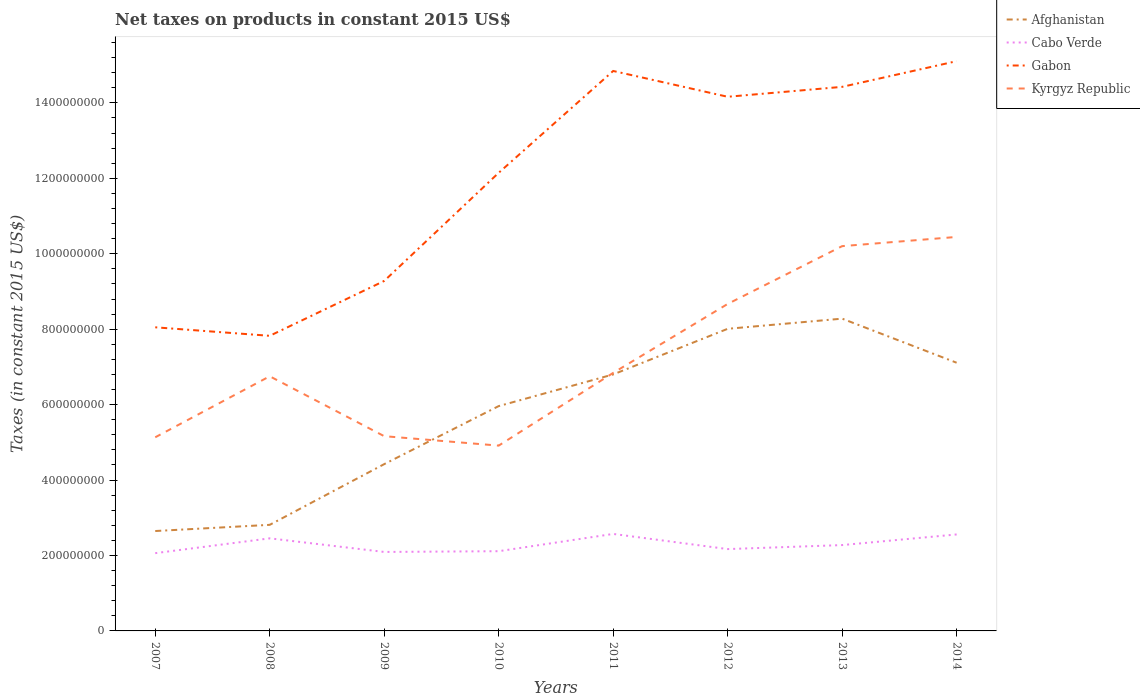Does the line corresponding to Gabon intersect with the line corresponding to Afghanistan?
Give a very brief answer. No. Across all years, what is the maximum net taxes on products in Afghanistan?
Give a very brief answer. 2.65e+08. In which year was the net taxes on products in Kyrgyz Republic maximum?
Offer a very short reply. 2010. What is the total net taxes on products in Afghanistan in the graph?
Offer a very short reply. -2.38e+08. What is the difference between the highest and the second highest net taxes on products in Cabo Verde?
Your response must be concise. 5.10e+07. What is the difference between the highest and the lowest net taxes on products in Afghanistan?
Offer a very short reply. 5. How many lines are there?
Your answer should be very brief. 4. How many years are there in the graph?
Make the answer very short. 8. What is the difference between two consecutive major ticks on the Y-axis?
Your answer should be compact. 2.00e+08. Does the graph contain any zero values?
Give a very brief answer. No. Does the graph contain grids?
Give a very brief answer. No. Where does the legend appear in the graph?
Your answer should be compact. Top right. What is the title of the graph?
Make the answer very short. Net taxes on products in constant 2015 US$. Does "Japan" appear as one of the legend labels in the graph?
Make the answer very short. No. What is the label or title of the X-axis?
Offer a terse response. Years. What is the label or title of the Y-axis?
Give a very brief answer. Taxes (in constant 2015 US$). What is the Taxes (in constant 2015 US$) of Afghanistan in 2007?
Offer a terse response. 2.65e+08. What is the Taxes (in constant 2015 US$) of Cabo Verde in 2007?
Your answer should be compact. 2.06e+08. What is the Taxes (in constant 2015 US$) of Gabon in 2007?
Provide a short and direct response. 8.05e+08. What is the Taxes (in constant 2015 US$) of Kyrgyz Republic in 2007?
Your answer should be very brief. 5.13e+08. What is the Taxes (in constant 2015 US$) in Afghanistan in 2008?
Your answer should be compact. 2.81e+08. What is the Taxes (in constant 2015 US$) in Cabo Verde in 2008?
Keep it short and to the point. 2.45e+08. What is the Taxes (in constant 2015 US$) of Gabon in 2008?
Your answer should be very brief. 7.82e+08. What is the Taxes (in constant 2015 US$) of Kyrgyz Republic in 2008?
Offer a terse response. 6.75e+08. What is the Taxes (in constant 2015 US$) of Afghanistan in 2009?
Provide a short and direct response. 4.42e+08. What is the Taxes (in constant 2015 US$) of Cabo Verde in 2009?
Ensure brevity in your answer.  2.09e+08. What is the Taxes (in constant 2015 US$) of Gabon in 2009?
Offer a very short reply. 9.28e+08. What is the Taxes (in constant 2015 US$) in Kyrgyz Republic in 2009?
Keep it short and to the point. 5.16e+08. What is the Taxes (in constant 2015 US$) of Afghanistan in 2010?
Offer a terse response. 5.96e+08. What is the Taxes (in constant 2015 US$) of Cabo Verde in 2010?
Your answer should be very brief. 2.11e+08. What is the Taxes (in constant 2015 US$) of Gabon in 2010?
Give a very brief answer. 1.21e+09. What is the Taxes (in constant 2015 US$) of Kyrgyz Republic in 2010?
Your response must be concise. 4.91e+08. What is the Taxes (in constant 2015 US$) of Afghanistan in 2011?
Keep it short and to the point. 6.80e+08. What is the Taxes (in constant 2015 US$) of Cabo Verde in 2011?
Keep it short and to the point. 2.57e+08. What is the Taxes (in constant 2015 US$) in Gabon in 2011?
Keep it short and to the point. 1.48e+09. What is the Taxes (in constant 2015 US$) of Kyrgyz Republic in 2011?
Provide a short and direct response. 6.84e+08. What is the Taxes (in constant 2015 US$) in Afghanistan in 2012?
Keep it short and to the point. 8.01e+08. What is the Taxes (in constant 2015 US$) in Cabo Verde in 2012?
Offer a very short reply. 2.17e+08. What is the Taxes (in constant 2015 US$) of Gabon in 2012?
Provide a short and direct response. 1.42e+09. What is the Taxes (in constant 2015 US$) in Kyrgyz Republic in 2012?
Offer a terse response. 8.67e+08. What is the Taxes (in constant 2015 US$) of Afghanistan in 2013?
Give a very brief answer. 8.28e+08. What is the Taxes (in constant 2015 US$) in Cabo Verde in 2013?
Keep it short and to the point. 2.28e+08. What is the Taxes (in constant 2015 US$) of Gabon in 2013?
Offer a very short reply. 1.44e+09. What is the Taxes (in constant 2015 US$) of Kyrgyz Republic in 2013?
Provide a succinct answer. 1.02e+09. What is the Taxes (in constant 2015 US$) in Afghanistan in 2014?
Provide a succinct answer. 7.11e+08. What is the Taxes (in constant 2015 US$) of Cabo Verde in 2014?
Offer a terse response. 2.56e+08. What is the Taxes (in constant 2015 US$) of Gabon in 2014?
Offer a terse response. 1.51e+09. What is the Taxes (in constant 2015 US$) in Kyrgyz Republic in 2014?
Your response must be concise. 1.04e+09. Across all years, what is the maximum Taxes (in constant 2015 US$) in Afghanistan?
Your answer should be very brief. 8.28e+08. Across all years, what is the maximum Taxes (in constant 2015 US$) of Cabo Verde?
Offer a very short reply. 2.57e+08. Across all years, what is the maximum Taxes (in constant 2015 US$) of Gabon?
Give a very brief answer. 1.51e+09. Across all years, what is the maximum Taxes (in constant 2015 US$) in Kyrgyz Republic?
Offer a terse response. 1.04e+09. Across all years, what is the minimum Taxes (in constant 2015 US$) in Afghanistan?
Offer a very short reply. 2.65e+08. Across all years, what is the minimum Taxes (in constant 2015 US$) in Cabo Verde?
Your answer should be very brief. 2.06e+08. Across all years, what is the minimum Taxes (in constant 2015 US$) in Gabon?
Ensure brevity in your answer.  7.82e+08. Across all years, what is the minimum Taxes (in constant 2015 US$) in Kyrgyz Republic?
Offer a terse response. 4.91e+08. What is the total Taxes (in constant 2015 US$) in Afghanistan in the graph?
Your response must be concise. 4.60e+09. What is the total Taxes (in constant 2015 US$) of Cabo Verde in the graph?
Give a very brief answer. 1.83e+09. What is the total Taxes (in constant 2015 US$) in Gabon in the graph?
Your answer should be compact. 9.58e+09. What is the total Taxes (in constant 2015 US$) in Kyrgyz Republic in the graph?
Give a very brief answer. 5.81e+09. What is the difference between the Taxes (in constant 2015 US$) in Afghanistan in 2007 and that in 2008?
Provide a succinct answer. -1.64e+07. What is the difference between the Taxes (in constant 2015 US$) in Cabo Verde in 2007 and that in 2008?
Your answer should be very brief. -3.93e+07. What is the difference between the Taxes (in constant 2015 US$) of Gabon in 2007 and that in 2008?
Your response must be concise. 2.26e+07. What is the difference between the Taxes (in constant 2015 US$) of Kyrgyz Republic in 2007 and that in 2008?
Your answer should be very brief. -1.62e+08. What is the difference between the Taxes (in constant 2015 US$) of Afghanistan in 2007 and that in 2009?
Make the answer very short. -1.77e+08. What is the difference between the Taxes (in constant 2015 US$) of Cabo Verde in 2007 and that in 2009?
Your answer should be compact. -3.21e+06. What is the difference between the Taxes (in constant 2015 US$) of Gabon in 2007 and that in 2009?
Provide a succinct answer. -1.23e+08. What is the difference between the Taxes (in constant 2015 US$) in Kyrgyz Republic in 2007 and that in 2009?
Keep it short and to the point. -2.94e+06. What is the difference between the Taxes (in constant 2015 US$) in Afghanistan in 2007 and that in 2010?
Give a very brief answer. -3.31e+08. What is the difference between the Taxes (in constant 2015 US$) of Cabo Verde in 2007 and that in 2010?
Your answer should be very brief. -5.19e+06. What is the difference between the Taxes (in constant 2015 US$) of Gabon in 2007 and that in 2010?
Offer a terse response. -4.10e+08. What is the difference between the Taxes (in constant 2015 US$) in Kyrgyz Republic in 2007 and that in 2010?
Your answer should be very brief. 2.21e+07. What is the difference between the Taxes (in constant 2015 US$) in Afghanistan in 2007 and that in 2011?
Your answer should be very brief. -4.15e+08. What is the difference between the Taxes (in constant 2015 US$) of Cabo Verde in 2007 and that in 2011?
Keep it short and to the point. -5.10e+07. What is the difference between the Taxes (in constant 2015 US$) of Gabon in 2007 and that in 2011?
Provide a succinct answer. -6.80e+08. What is the difference between the Taxes (in constant 2015 US$) in Kyrgyz Republic in 2007 and that in 2011?
Your answer should be very brief. -1.71e+08. What is the difference between the Taxes (in constant 2015 US$) of Afghanistan in 2007 and that in 2012?
Make the answer very short. -5.36e+08. What is the difference between the Taxes (in constant 2015 US$) of Cabo Verde in 2007 and that in 2012?
Offer a very short reply. -1.08e+07. What is the difference between the Taxes (in constant 2015 US$) in Gabon in 2007 and that in 2012?
Your response must be concise. -6.11e+08. What is the difference between the Taxes (in constant 2015 US$) in Kyrgyz Republic in 2007 and that in 2012?
Offer a very short reply. -3.54e+08. What is the difference between the Taxes (in constant 2015 US$) in Afghanistan in 2007 and that in 2013?
Your answer should be compact. -5.63e+08. What is the difference between the Taxes (in constant 2015 US$) of Cabo Verde in 2007 and that in 2013?
Ensure brevity in your answer.  -2.14e+07. What is the difference between the Taxes (in constant 2015 US$) of Gabon in 2007 and that in 2013?
Provide a short and direct response. -6.38e+08. What is the difference between the Taxes (in constant 2015 US$) of Kyrgyz Republic in 2007 and that in 2013?
Keep it short and to the point. -5.07e+08. What is the difference between the Taxes (in constant 2015 US$) in Afghanistan in 2007 and that in 2014?
Your answer should be compact. -4.46e+08. What is the difference between the Taxes (in constant 2015 US$) of Cabo Verde in 2007 and that in 2014?
Give a very brief answer. -4.96e+07. What is the difference between the Taxes (in constant 2015 US$) in Gabon in 2007 and that in 2014?
Ensure brevity in your answer.  -7.06e+08. What is the difference between the Taxes (in constant 2015 US$) in Kyrgyz Republic in 2007 and that in 2014?
Your answer should be very brief. -5.31e+08. What is the difference between the Taxes (in constant 2015 US$) in Afghanistan in 2008 and that in 2009?
Give a very brief answer. -1.61e+08. What is the difference between the Taxes (in constant 2015 US$) in Cabo Verde in 2008 and that in 2009?
Offer a terse response. 3.61e+07. What is the difference between the Taxes (in constant 2015 US$) of Gabon in 2008 and that in 2009?
Keep it short and to the point. -1.45e+08. What is the difference between the Taxes (in constant 2015 US$) of Kyrgyz Republic in 2008 and that in 2009?
Give a very brief answer. 1.59e+08. What is the difference between the Taxes (in constant 2015 US$) in Afghanistan in 2008 and that in 2010?
Make the answer very short. -3.15e+08. What is the difference between the Taxes (in constant 2015 US$) in Cabo Verde in 2008 and that in 2010?
Provide a short and direct response. 3.41e+07. What is the difference between the Taxes (in constant 2015 US$) of Gabon in 2008 and that in 2010?
Your answer should be compact. -4.32e+08. What is the difference between the Taxes (in constant 2015 US$) in Kyrgyz Republic in 2008 and that in 2010?
Your answer should be very brief. 1.84e+08. What is the difference between the Taxes (in constant 2015 US$) in Afghanistan in 2008 and that in 2011?
Ensure brevity in your answer.  -3.99e+08. What is the difference between the Taxes (in constant 2015 US$) of Cabo Verde in 2008 and that in 2011?
Keep it short and to the point. -1.17e+07. What is the difference between the Taxes (in constant 2015 US$) in Gabon in 2008 and that in 2011?
Give a very brief answer. -7.02e+08. What is the difference between the Taxes (in constant 2015 US$) of Kyrgyz Republic in 2008 and that in 2011?
Your answer should be very brief. -8.96e+06. What is the difference between the Taxes (in constant 2015 US$) in Afghanistan in 2008 and that in 2012?
Ensure brevity in your answer.  -5.20e+08. What is the difference between the Taxes (in constant 2015 US$) of Cabo Verde in 2008 and that in 2012?
Keep it short and to the point. 2.85e+07. What is the difference between the Taxes (in constant 2015 US$) in Gabon in 2008 and that in 2012?
Keep it short and to the point. -6.34e+08. What is the difference between the Taxes (in constant 2015 US$) in Kyrgyz Republic in 2008 and that in 2012?
Make the answer very short. -1.92e+08. What is the difference between the Taxes (in constant 2015 US$) of Afghanistan in 2008 and that in 2013?
Offer a very short reply. -5.47e+08. What is the difference between the Taxes (in constant 2015 US$) of Cabo Verde in 2008 and that in 2013?
Make the answer very short. 1.79e+07. What is the difference between the Taxes (in constant 2015 US$) of Gabon in 2008 and that in 2013?
Provide a succinct answer. -6.60e+08. What is the difference between the Taxes (in constant 2015 US$) of Kyrgyz Republic in 2008 and that in 2013?
Provide a short and direct response. -3.45e+08. What is the difference between the Taxes (in constant 2015 US$) of Afghanistan in 2008 and that in 2014?
Provide a succinct answer. -4.30e+08. What is the difference between the Taxes (in constant 2015 US$) of Cabo Verde in 2008 and that in 2014?
Offer a terse response. -1.03e+07. What is the difference between the Taxes (in constant 2015 US$) in Gabon in 2008 and that in 2014?
Offer a terse response. -7.28e+08. What is the difference between the Taxes (in constant 2015 US$) in Kyrgyz Republic in 2008 and that in 2014?
Keep it short and to the point. -3.69e+08. What is the difference between the Taxes (in constant 2015 US$) of Afghanistan in 2009 and that in 2010?
Offer a very short reply. -1.54e+08. What is the difference between the Taxes (in constant 2015 US$) in Cabo Verde in 2009 and that in 2010?
Offer a very short reply. -1.98e+06. What is the difference between the Taxes (in constant 2015 US$) of Gabon in 2009 and that in 2010?
Your answer should be very brief. -2.87e+08. What is the difference between the Taxes (in constant 2015 US$) of Kyrgyz Republic in 2009 and that in 2010?
Keep it short and to the point. 2.50e+07. What is the difference between the Taxes (in constant 2015 US$) in Afghanistan in 2009 and that in 2011?
Your answer should be very brief. -2.38e+08. What is the difference between the Taxes (in constant 2015 US$) of Cabo Verde in 2009 and that in 2011?
Provide a succinct answer. -4.78e+07. What is the difference between the Taxes (in constant 2015 US$) of Gabon in 2009 and that in 2011?
Offer a terse response. -5.57e+08. What is the difference between the Taxes (in constant 2015 US$) in Kyrgyz Republic in 2009 and that in 2011?
Provide a short and direct response. -1.68e+08. What is the difference between the Taxes (in constant 2015 US$) of Afghanistan in 2009 and that in 2012?
Provide a short and direct response. -3.59e+08. What is the difference between the Taxes (in constant 2015 US$) of Cabo Verde in 2009 and that in 2012?
Offer a very short reply. -7.58e+06. What is the difference between the Taxes (in constant 2015 US$) of Gabon in 2009 and that in 2012?
Offer a terse response. -4.88e+08. What is the difference between the Taxes (in constant 2015 US$) in Kyrgyz Republic in 2009 and that in 2012?
Offer a very short reply. -3.51e+08. What is the difference between the Taxes (in constant 2015 US$) of Afghanistan in 2009 and that in 2013?
Keep it short and to the point. -3.86e+08. What is the difference between the Taxes (in constant 2015 US$) in Cabo Verde in 2009 and that in 2013?
Ensure brevity in your answer.  -1.82e+07. What is the difference between the Taxes (in constant 2015 US$) in Gabon in 2009 and that in 2013?
Make the answer very short. -5.15e+08. What is the difference between the Taxes (in constant 2015 US$) in Kyrgyz Republic in 2009 and that in 2013?
Offer a very short reply. -5.04e+08. What is the difference between the Taxes (in constant 2015 US$) in Afghanistan in 2009 and that in 2014?
Ensure brevity in your answer.  -2.69e+08. What is the difference between the Taxes (in constant 2015 US$) of Cabo Verde in 2009 and that in 2014?
Make the answer very short. -4.64e+07. What is the difference between the Taxes (in constant 2015 US$) in Gabon in 2009 and that in 2014?
Your response must be concise. -5.83e+08. What is the difference between the Taxes (in constant 2015 US$) in Kyrgyz Republic in 2009 and that in 2014?
Give a very brief answer. -5.28e+08. What is the difference between the Taxes (in constant 2015 US$) in Afghanistan in 2010 and that in 2011?
Offer a terse response. -8.40e+07. What is the difference between the Taxes (in constant 2015 US$) in Cabo Verde in 2010 and that in 2011?
Give a very brief answer. -4.58e+07. What is the difference between the Taxes (in constant 2015 US$) of Gabon in 2010 and that in 2011?
Offer a terse response. -2.70e+08. What is the difference between the Taxes (in constant 2015 US$) of Kyrgyz Republic in 2010 and that in 2011?
Your response must be concise. -1.93e+08. What is the difference between the Taxes (in constant 2015 US$) in Afghanistan in 2010 and that in 2012?
Keep it short and to the point. -2.05e+08. What is the difference between the Taxes (in constant 2015 US$) of Cabo Verde in 2010 and that in 2012?
Your answer should be compact. -5.61e+06. What is the difference between the Taxes (in constant 2015 US$) in Gabon in 2010 and that in 2012?
Your answer should be compact. -2.02e+08. What is the difference between the Taxes (in constant 2015 US$) in Kyrgyz Republic in 2010 and that in 2012?
Offer a terse response. -3.76e+08. What is the difference between the Taxes (in constant 2015 US$) of Afghanistan in 2010 and that in 2013?
Give a very brief answer. -2.32e+08. What is the difference between the Taxes (in constant 2015 US$) in Cabo Verde in 2010 and that in 2013?
Provide a short and direct response. -1.62e+07. What is the difference between the Taxes (in constant 2015 US$) in Gabon in 2010 and that in 2013?
Provide a short and direct response. -2.28e+08. What is the difference between the Taxes (in constant 2015 US$) in Kyrgyz Republic in 2010 and that in 2013?
Offer a very short reply. -5.29e+08. What is the difference between the Taxes (in constant 2015 US$) of Afghanistan in 2010 and that in 2014?
Ensure brevity in your answer.  -1.15e+08. What is the difference between the Taxes (in constant 2015 US$) of Cabo Verde in 2010 and that in 2014?
Your answer should be compact. -4.44e+07. What is the difference between the Taxes (in constant 2015 US$) of Gabon in 2010 and that in 2014?
Provide a short and direct response. -2.96e+08. What is the difference between the Taxes (in constant 2015 US$) of Kyrgyz Republic in 2010 and that in 2014?
Your response must be concise. -5.53e+08. What is the difference between the Taxes (in constant 2015 US$) of Afghanistan in 2011 and that in 2012?
Offer a terse response. -1.21e+08. What is the difference between the Taxes (in constant 2015 US$) of Cabo Verde in 2011 and that in 2012?
Provide a short and direct response. 4.02e+07. What is the difference between the Taxes (in constant 2015 US$) of Gabon in 2011 and that in 2012?
Offer a very short reply. 6.84e+07. What is the difference between the Taxes (in constant 2015 US$) of Kyrgyz Republic in 2011 and that in 2012?
Make the answer very short. -1.83e+08. What is the difference between the Taxes (in constant 2015 US$) of Afghanistan in 2011 and that in 2013?
Your answer should be very brief. -1.48e+08. What is the difference between the Taxes (in constant 2015 US$) of Cabo Verde in 2011 and that in 2013?
Provide a succinct answer. 2.96e+07. What is the difference between the Taxes (in constant 2015 US$) of Gabon in 2011 and that in 2013?
Offer a very short reply. 4.21e+07. What is the difference between the Taxes (in constant 2015 US$) in Kyrgyz Republic in 2011 and that in 2013?
Offer a very short reply. -3.36e+08. What is the difference between the Taxes (in constant 2015 US$) in Afghanistan in 2011 and that in 2014?
Make the answer very short. -3.11e+07. What is the difference between the Taxes (in constant 2015 US$) of Cabo Verde in 2011 and that in 2014?
Offer a very short reply. 1.39e+06. What is the difference between the Taxes (in constant 2015 US$) of Gabon in 2011 and that in 2014?
Provide a short and direct response. -2.60e+07. What is the difference between the Taxes (in constant 2015 US$) in Kyrgyz Republic in 2011 and that in 2014?
Give a very brief answer. -3.60e+08. What is the difference between the Taxes (in constant 2015 US$) in Afghanistan in 2012 and that in 2013?
Provide a succinct answer. -2.70e+07. What is the difference between the Taxes (in constant 2015 US$) in Cabo Verde in 2012 and that in 2013?
Keep it short and to the point. -1.06e+07. What is the difference between the Taxes (in constant 2015 US$) in Gabon in 2012 and that in 2013?
Ensure brevity in your answer.  -2.63e+07. What is the difference between the Taxes (in constant 2015 US$) in Kyrgyz Republic in 2012 and that in 2013?
Give a very brief answer. -1.53e+08. What is the difference between the Taxes (in constant 2015 US$) of Afghanistan in 2012 and that in 2014?
Keep it short and to the point. 8.99e+07. What is the difference between the Taxes (in constant 2015 US$) of Cabo Verde in 2012 and that in 2014?
Offer a very short reply. -3.88e+07. What is the difference between the Taxes (in constant 2015 US$) in Gabon in 2012 and that in 2014?
Provide a succinct answer. -9.44e+07. What is the difference between the Taxes (in constant 2015 US$) in Kyrgyz Republic in 2012 and that in 2014?
Keep it short and to the point. -1.78e+08. What is the difference between the Taxes (in constant 2015 US$) of Afghanistan in 2013 and that in 2014?
Provide a succinct answer. 1.17e+08. What is the difference between the Taxes (in constant 2015 US$) of Cabo Verde in 2013 and that in 2014?
Keep it short and to the point. -2.82e+07. What is the difference between the Taxes (in constant 2015 US$) in Gabon in 2013 and that in 2014?
Keep it short and to the point. -6.81e+07. What is the difference between the Taxes (in constant 2015 US$) in Kyrgyz Republic in 2013 and that in 2014?
Make the answer very short. -2.44e+07. What is the difference between the Taxes (in constant 2015 US$) in Afghanistan in 2007 and the Taxes (in constant 2015 US$) in Cabo Verde in 2008?
Provide a succinct answer. 1.94e+07. What is the difference between the Taxes (in constant 2015 US$) in Afghanistan in 2007 and the Taxes (in constant 2015 US$) in Gabon in 2008?
Provide a succinct answer. -5.18e+08. What is the difference between the Taxes (in constant 2015 US$) of Afghanistan in 2007 and the Taxes (in constant 2015 US$) of Kyrgyz Republic in 2008?
Offer a terse response. -4.10e+08. What is the difference between the Taxes (in constant 2015 US$) of Cabo Verde in 2007 and the Taxes (in constant 2015 US$) of Gabon in 2008?
Your answer should be compact. -5.76e+08. What is the difference between the Taxes (in constant 2015 US$) in Cabo Verde in 2007 and the Taxes (in constant 2015 US$) in Kyrgyz Republic in 2008?
Keep it short and to the point. -4.69e+08. What is the difference between the Taxes (in constant 2015 US$) of Gabon in 2007 and the Taxes (in constant 2015 US$) of Kyrgyz Republic in 2008?
Your answer should be compact. 1.30e+08. What is the difference between the Taxes (in constant 2015 US$) of Afghanistan in 2007 and the Taxes (in constant 2015 US$) of Cabo Verde in 2009?
Offer a very short reply. 5.55e+07. What is the difference between the Taxes (in constant 2015 US$) in Afghanistan in 2007 and the Taxes (in constant 2015 US$) in Gabon in 2009?
Make the answer very short. -6.63e+08. What is the difference between the Taxes (in constant 2015 US$) of Afghanistan in 2007 and the Taxes (in constant 2015 US$) of Kyrgyz Republic in 2009?
Your answer should be very brief. -2.51e+08. What is the difference between the Taxes (in constant 2015 US$) in Cabo Verde in 2007 and the Taxes (in constant 2015 US$) in Gabon in 2009?
Offer a very short reply. -7.22e+08. What is the difference between the Taxes (in constant 2015 US$) of Cabo Verde in 2007 and the Taxes (in constant 2015 US$) of Kyrgyz Republic in 2009?
Your answer should be very brief. -3.10e+08. What is the difference between the Taxes (in constant 2015 US$) in Gabon in 2007 and the Taxes (in constant 2015 US$) in Kyrgyz Republic in 2009?
Your answer should be very brief. 2.89e+08. What is the difference between the Taxes (in constant 2015 US$) of Afghanistan in 2007 and the Taxes (in constant 2015 US$) of Cabo Verde in 2010?
Offer a very short reply. 5.35e+07. What is the difference between the Taxes (in constant 2015 US$) of Afghanistan in 2007 and the Taxes (in constant 2015 US$) of Gabon in 2010?
Offer a terse response. -9.50e+08. What is the difference between the Taxes (in constant 2015 US$) of Afghanistan in 2007 and the Taxes (in constant 2015 US$) of Kyrgyz Republic in 2010?
Your answer should be compact. -2.26e+08. What is the difference between the Taxes (in constant 2015 US$) in Cabo Verde in 2007 and the Taxes (in constant 2015 US$) in Gabon in 2010?
Give a very brief answer. -1.01e+09. What is the difference between the Taxes (in constant 2015 US$) in Cabo Verde in 2007 and the Taxes (in constant 2015 US$) in Kyrgyz Republic in 2010?
Offer a terse response. -2.85e+08. What is the difference between the Taxes (in constant 2015 US$) of Gabon in 2007 and the Taxes (in constant 2015 US$) of Kyrgyz Republic in 2010?
Your answer should be compact. 3.14e+08. What is the difference between the Taxes (in constant 2015 US$) in Afghanistan in 2007 and the Taxes (in constant 2015 US$) in Cabo Verde in 2011?
Ensure brevity in your answer.  7.68e+06. What is the difference between the Taxes (in constant 2015 US$) in Afghanistan in 2007 and the Taxes (in constant 2015 US$) in Gabon in 2011?
Make the answer very short. -1.22e+09. What is the difference between the Taxes (in constant 2015 US$) of Afghanistan in 2007 and the Taxes (in constant 2015 US$) of Kyrgyz Republic in 2011?
Provide a succinct answer. -4.19e+08. What is the difference between the Taxes (in constant 2015 US$) of Cabo Verde in 2007 and the Taxes (in constant 2015 US$) of Gabon in 2011?
Offer a very short reply. -1.28e+09. What is the difference between the Taxes (in constant 2015 US$) of Cabo Verde in 2007 and the Taxes (in constant 2015 US$) of Kyrgyz Republic in 2011?
Keep it short and to the point. -4.78e+08. What is the difference between the Taxes (in constant 2015 US$) in Gabon in 2007 and the Taxes (in constant 2015 US$) in Kyrgyz Republic in 2011?
Offer a very short reply. 1.21e+08. What is the difference between the Taxes (in constant 2015 US$) in Afghanistan in 2007 and the Taxes (in constant 2015 US$) in Cabo Verde in 2012?
Your answer should be compact. 4.79e+07. What is the difference between the Taxes (in constant 2015 US$) in Afghanistan in 2007 and the Taxes (in constant 2015 US$) in Gabon in 2012?
Keep it short and to the point. -1.15e+09. What is the difference between the Taxes (in constant 2015 US$) in Afghanistan in 2007 and the Taxes (in constant 2015 US$) in Kyrgyz Republic in 2012?
Provide a succinct answer. -6.02e+08. What is the difference between the Taxes (in constant 2015 US$) of Cabo Verde in 2007 and the Taxes (in constant 2015 US$) of Gabon in 2012?
Your response must be concise. -1.21e+09. What is the difference between the Taxes (in constant 2015 US$) in Cabo Verde in 2007 and the Taxes (in constant 2015 US$) in Kyrgyz Republic in 2012?
Offer a very short reply. -6.61e+08. What is the difference between the Taxes (in constant 2015 US$) of Gabon in 2007 and the Taxes (in constant 2015 US$) of Kyrgyz Republic in 2012?
Keep it short and to the point. -6.19e+07. What is the difference between the Taxes (in constant 2015 US$) of Afghanistan in 2007 and the Taxes (in constant 2015 US$) of Cabo Verde in 2013?
Your answer should be compact. 3.72e+07. What is the difference between the Taxes (in constant 2015 US$) of Afghanistan in 2007 and the Taxes (in constant 2015 US$) of Gabon in 2013?
Give a very brief answer. -1.18e+09. What is the difference between the Taxes (in constant 2015 US$) in Afghanistan in 2007 and the Taxes (in constant 2015 US$) in Kyrgyz Republic in 2013?
Provide a succinct answer. -7.55e+08. What is the difference between the Taxes (in constant 2015 US$) in Cabo Verde in 2007 and the Taxes (in constant 2015 US$) in Gabon in 2013?
Ensure brevity in your answer.  -1.24e+09. What is the difference between the Taxes (in constant 2015 US$) in Cabo Verde in 2007 and the Taxes (in constant 2015 US$) in Kyrgyz Republic in 2013?
Make the answer very short. -8.14e+08. What is the difference between the Taxes (in constant 2015 US$) of Gabon in 2007 and the Taxes (in constant 2015 US$) of Kyrgyz Republic in 2013?
Give a very brief answer. -2.15e+08. What is the difference between the Taxes (in constant 2015 US$) of Afghanistan in 2007 and the Taxes (in constant 2015 US$) of Cabo Verde in 2014?
Your answer should be very brief. 9.06e+06. What is the difference between the Taxes (in constant 2015 US$) in Afghanistan in 2007 and the Taxes (in constant 2015 US$) in Gabon in 2014?
Provide a short and direct response. -1.25e+09. What is the difference between the Taxes (in constant 2015 US$) in Afghanistan in 2007 and the Taxes (in constant 2015 US$) in Kyrgyz Republic in 2014?
Your answer should be compact. -7.80e+08. What is the difference between the Taxes (in constant 2015 US$) in Cabo Verde in 2007 and the Taxes (in constant 2015 US$) in Gabon in 2014?
Offer a very short reply. -1.30e+09. What is the difference between the Taxes (in constant 2015 US$) in Cabo Verde in 2007 and the Taxes (in constant 2015 US$) in Kyrgyz Republic in 2014?
Your answer should be compact. -8.38e+08. What is the difference between the Taxes (in constant 2015 US$) in Gabon in 2007 and the Taxes (in constant 2015 US$) in Kyrgyz Republic in 2014?
Your answer should be compact. -2.40e+08. What is the difference between the Taxes (in constant 2015 US$) in Afghanistan in 2008 and the Taxes (in constant 2015 US$) in Cabo Verde in 2009?
Keep it short and to the point. 7.19e+07. What is the difference between the Taxes (in constant 2015 US$) of Afghanistan in 2008 and the Taxes (in constant 2015 US$) of Gabon in 2009?
Offer a terse response. -6.47e+08. What is the difference between the Taxes (in constant 2015 US$) of Afghanistan in 2008 and the Taxes (in constant 2015 US$) of Kyrgyz Republic in 2009?
Your answer should be very brief. -2.35e+08. What is the difference between the Taxes (in constant 2015 US$) in Cabo Verde in 2008 and the Taxes (in constant 2015 US$) in Gabon in 2009?
Offer a very short reply. -6.82e+08. What is the difference between the Taxes (in constant 2015 US$) in Cabo Verde in 2008 and the Taxes (in constant 2015 US$) in Kyrgyz Republic in 2009?
Offer a very short reply. -2.71e+08. What is the difference between the Taxes (in constant 2015 US$) in Gabon in 2008 and the Taxes (in constant 2015 US$) in Kyrgyz Republic in 2009?
Provide a short and direct response. 2.66e+08. What is the difference between the Taxes (in constant 2015 US$) of Afghanistan in 2008 and the Taxes (in constant 2015 US$) of Cabo Verde in 2010?
Make the answer very short. 6.99e+07. What is the difference between the Taxes (in constant 2015 US$) of Afghanistan in 2008 and the Taxes (in constant 2015 US$) of Gabon in 2010?
Offer a terse response. -9.33e+08. What is the difference between the Taxes (in constant 2015 US$) in Afghanistan in 2008 and the Taxes (in constant 2015 US$) in Kyrgyz Republic in 2010?
Ensure brevity in your answer.  -2.10e+08. What is the difference between the Taxes (in constant 2015 US$) of Cabo Verde in 2008 and the Taxes (in constant 2015 US$) of Gabon in 2010?
Ensure brevity in your answer.  -9.69e+08. What is the difference between the Taxes (in constant 2015 US$) in Cabo Verde in 2008 and the Taxes (in constant 2015 US$) in Kyrgyz Republic in 2010?
Your answer should be very brief. -2.46e+08. What is the difference between the Taxes (in constant 2015 US$) of Gabon in 2008 and the Taxes (in constant 2015 US$) of Kyrgyz Republic in 2010?
Provide a succinct answer. 2.91e+08. What is the difference between the Taxes (in constant 2015 US$) of Afghanistan in 2008 and the Taxes (in constant 2015 US$) of Cabo Verde in 2011?
Provide a short and direct response. 2.41e+07. What is the difference between the Taxes (in constant 2015 US$) of Afghanistan in 2008 and the Taxes (in constant 2015 US$) of Gabon in 2011?
Your answer should be compact. -1.20e+09. What is the difference between the Taxes (in constant 2015 US$) of Afghanistan in 2008 and the Taxes (in constant 2015 US$) of Kyrgyz Republic in 2011?
Ensure brevity in your answer.  -4.03e+08. What is the difference between the Taxes (in constant 2015 US$) of Cabo Verde in 2008 and the Taxes (in constant 2015 US$) of Gabon in 2011?
Give a very brief answer. -1.24e+09. What is the difference between the Taxes (in constant 2015 US$) in Cabo Verde in 2008 and the Taxes (in constant 2015 US$) in Kyrgyz Republic in 2011?
Provide a succinct answer. -4.39e+08. What is the difference between the Taxes (in constant 2015 US$) of Gabon in 2008 and the Taxes (in constant 2015 US$) of Kyrgyz Republic in 2011?
Make the answer very short. 9.83e+07. What is the difference between the Taxes (in constant 2015 US$) of Afghanistan in 2008 and the Taxes (in constant 2015 US$) of Cabo Verde in 2012?
Keep it short and to the point. 6.43e+07. What is the difference between the Taxes (in constant 2015 US$) of Afghanistan in 2008 and the Taxes (in constant 2015 US$) of Gabon in 2012?
Provide a succinct answer. -1.13e+09. What is the difference between the Taxes (in constant 2015 US$) of Afghanistan in 2008 and the Taxes (in constant 2015 US$) of Kyrgyz Republic in 2012?
Your answer should be compact. -5.86e+08. What is the difference between the Taxes (in constant 2015 US$) of Cabo Verde in 2008 and the Taxes (in constant 2015 US$) of Gabon in 2012?
Keep it short and to the point. -1.17e+09. What is the difference between the Taxes (in constant 2015 US$) in Cabo Verde in 2008 and the Taxes (in constant 2015 US$) in Kyrgyz Republic in 2012?
Make the answer very short. -6.21e+08. What is the difference between the Taxes (in constant 2015 US$) in Gabon in 2008 and the Taxes (in constant 2015 US$) in Kyrgyz Republic in 2012?
Make the answer very short. -8.45e+07. What is the difference between the Taxes (in constant 2015 US$) in Afghanistan in 2008 and the Taxes (in constant 2015 US$) in Cabo Verde in 2013?
Provide a short and direct response. 5.37e+07. What is the difference between the Taxes (in constant 2015 US$) in Afghanistan in 2008 and the Taxes (in constant 2015 US$) in Gabon in 2013?
Give a very brief answer. -1.16e+09. What is the difference between the Taxes (in constant 2015 US$) of Afghanistan in 2008 and the Taxes (in constant 2015 US$) of Kyrgyz Republic in 2013?
Offer a terse response. -7.39e+08. What is the difference between the Taxes (in constant 2015 US$) in Cabo Verde in 2008 and the Taxes (in constant 2015 US$) in Gabon in 2013?
Keep it short and to the point. -1.20e+09. What is the difference between the Taxes (in constant 2015 US$) in Cabo Verde in 2008 and the Taxes (in constant 2015 US$) in Kyrgyz Republic in 2013?
Keep it short and to the point. -7.75e+08. What is the difference between the Taxes (in constant 2015 US$) in Gabon in 2008 and the Taxes (in constant 2015 US$) in Kyrgyz Republic in 2013?
Provide a succinct answer. -2.38e+08. What is the difference between the Taxes (in constant 2015 US$) of Afghanistan in 2008 and the Taxes (in constant 2015 US$) of Cabo Verde in 2014?
Your answer should be very brief. 2.55e+07. What is the difference between the Taxes (in constant 2015 US$) of Afghanistan in 2008 and the Taxes (in constant 2015 US$) of Gabon in 2014?
Offer a terse response. -1.23e+09. What is the difference between the Taxes (in constant 2015 US$) of Afghanistan in 2008 and the Taxes (in constant 2015 US$) of Kyrgyz Republic in 2014?
Your answer should be very brief. -7.63e+08. What is the difference between the Taxes (in constant 2015 US$) in Cabo Verde in 2008 and the Taxes (in constant 2015 US$) in Gabon in 2014?
Your answer should be compact. -1.27e+09. What is the difference between the Taxes (in constant 2015 US$) in Cabo Verde in 2008 and the Taxes (in constant 2015 US$) in Kyrgyz Republic in 2014?
Your response must be concise. -7.99e+08. What is the difference between the Taxes (in constant 2015 US$) in Gabon in 2008 and the Taxes (in constant 2015 US$) in Kyrgyz Republic in 2014?
Ensure brevity in your answer.  -2.62e+08. What is the difference between the Taxes (in constant 2015 US$) in Afghanistan in 2009 and the Taxes (in constant 2015 US$) in Cabo Verde in 2010?
Your answer should be very brief. 2.31e+08. What is the difference between the Taxes (in constant 2015 US$) of Afghanistan in 2009 and the Taxes (in constant 2015 US$) of Gabon in 2010?
Your response must be concise. -7.72e+08. What is the difference between the Taxes (in constant 2015 US$) in Afghanistan in 2009 and the Taxes (in constant 2015 US$) in Kyrgyz Republic in 2010?
Keep it short and to the point. -4.91e+07. What is the difference between the Taxes (in constant 2015 US$) in Cabo Verde in 2009 and the Taxes (in constant 2015 US$) in Gabon in 2010?
Offer a very short reply. -1.01e+09. What is the difference between the Taxes (in constant 2015 US$) of Cabo Verde in 2009 and the Taxes (in constant 2015 US$) of Kyrgyz Republic in 2010?
Offer a terse response. -2.82e+08. What is the difference between the Taxes (in constant 2015 US$) in Gabon in 2009 and the Taxes (in constant 2015 US$) in Kyrgyz Republic in 2010?
Ensure brevity in your answer.  4.37e+08. What is the difference between the Taxes (in constant 2015 US$) of Afghanistan in 2009 and the Taxes (in constant 2015 US$) of Cabo Verde in 2011?
Keep it short and to the point. 1.85e+08. What is the difference between the Taxes (in constant 2015 US$) in Afghanistan in 2009 and the Taxes (in constant 2015 US$) in Gabon in 2011?
Your response must be concise. -1.04e+09. What is the difference between the Taxes (in constant 2015 US$) in Afghanistan in 2009 and the Taxes (in constant 2015 US$) in Kyrgyz Republic in 2011?
Offer a terse response. -2.42e+08. What is the difference between the Taxes (in constant 2015 US$) in Cabo Verde in 2009 and the Taxes (in constant 2015 US$) in Gabon in 2011?
Keep it short and to the point. -1.28e+09. What is the difference between the Taxes (in constant 2015 US$) of Cabo Verde in 2009 and the Taxes (in constant 2015 US$) of Kyrgyz Republic in 2011?
Your answer should be compact. -4.75e+08. What is the difference between the Taxes (in constant 2015 US$) of Gabon in 2009 and the Taxes (in constant 2015 US$) of Kyrgyz Republic in 2011?
Your response must be concise. 2.44e+08. What is the difference between the Taxes (in constant 2015 US$) of Afghanistan in 2009 and the Taxes (in constant 2015 US$) of Cabo Verde in 2012?
Make the answer very short. 2.25e+08. What is the difference between the Taxes (in constant 2015 US$) in Afghanistan in 2009 and the Taxes (in constant 2015 US$) in Gabon in 2012?
Ensure brevity in your answer.  -9.74e+08. What is the difference between the Taxes (in constant 2015 US$) of Afghanistan in 2009 and the Taxes (in constant 2015 US$) of Kyrgyz Republic in 2012?
Keep it short and to the point. -4.25e+08. What is the difference between the Taxes (in constant 2015 US$) of Cabo Verde in 2009 and the Taxes (in constant 2015 US$) of Gabon in 2012?
Provide a succinct answer. -1.21e+09. What is the difference between the Taxes (in constant 2015 US$) of Cabo Verde in 2009 and the Taxes (in constant 2015 US$) of Kyrgyz Republic in 2012?
Give a very brief answer. -6.58e+08. What is the difference between the Taxes (in constant 2015 US$) of Gabon in 2009 and the Taxes (in constant 2015 US$) of Kyrgyz Republic in 2012?
Offer a very short reply. 6.10e+07. What is the difference between the Taxes (in constant 2015 US$) in Afghanistan in 2009 and the Taxes (in constant 2015 US$) in Cabo Verde in 2013?
Make the answer very short. 2.15e+08. What is the difference between the Taxes (in constant 2015 US$) in Afghanistan in 2009 and the Taxes (in constant 2015 US$) in Gabon in 2013?
Make the answer very short. -1.00e+09. What is the difference between the Taxes (in constant 2015 US$) in Afghanistan in 2009 and the Taxes (in constant 2015 US$) in Kyrgyz Republic in 2013?
Your response must be concise. -5.78e+08. What is the difference between the Taxes (in constant 2015 US$) of Cabo Verde in 2009 and the Taxes (in constant 2015 US$) of Gabon in 2013?
Give a very brief answer. -1.23e+09. What is the difference between the Taxes (in constant 2015 US$) in Cabo Verde in 2009 and the Taxes (in constant 2015 US$) in Kyrgyz Republic in 2013?
Provide a succinct answer. -8.11e+08. What is the difference between the Taxes (in constant 2015 US$) of Gabon in 2009 and the Taxes (in constant 2015 US$) of Kyrgyz Republic in 2013?
Offer a terse response. -9.23e+07. What is the difference between the Taxes (in constant 2015 US$) in Afghanistan in 2009 and the Taxes (in constant 2015 US$) in Cabo Verde in 2014?
Your response must be concise. 1.86e+08. What is the difference between the Taxes (in constant 2015 US$) of Afghanistan in 2009 and the Taxes (in constant 2015 US$) of Gabon in 2014?
Keep it short and to the point. -1.07e+09. What is the difference between the Taxes (in constant 2015 US$) in Afghanistan in 2009 and the Taxes (in constant 2015 US$) in Kyrgyz Republic in 2014?
Your answer should be very brief. -6.02e+08. What is the difference between the Taxes (in constant 2015 US$) of Cabo Verde in 2009 and the Taxes (in constant 2015 US$) of Gabon in 2014?
Ensure brevity in your answer.  -1.30e+09. What is the difference between the Taxes (in constant 2015 US$) in Cabo Verde in 2009 and the Taxes (in constant 2015 US$) in Kyrgyz Republic in 2014?
Make the answer very short. -8.35e+08. What is the difference between the Taxes (in constant 2015 US$) of Gabon in 2009 and the Taxes (in constant 2015 US$) of Kyrgyz Republic in 2014?
Keep it short and to the point. -1.17e+08. What is the difference between the Taxes (in constant 2015 US$) in Afghanistan in 2010 and the Taxes (in constant 2015 US$) in Cabo Verde in 2011?
Your answer should be compact. 3.39e+08. What is the difference between the Taxes (in constant 2015 US$) in Afghanistan in 2010 and the Taxes (in constant 2015 US$) in Gabon in 2011?
Your answer should be very brief. -8.89e+08. What is the difference between the Taxes (in constant 2015 US$) in Afghanistan in 2010 and the Taxes (in constant 2015 US$) in Kyrgyz Republic in 2011?
Offer a terse response. -8.80e+07. What is the difference between the Taxes (in constant 2015 US$) of Cabo Verde in 2010 and the Taxes (in constant 2015 US$) of Gabon in 2011?
Your answer should be compact. -1.27e+09. What is the difference between the Taxes (in constant 2015 US$) in Cabo Verde in 2010 and the Taxes (in constant 2015 US$) in Kyrgyz Republic in 2011?
Offer a very short reply. -4.73e+08. What is the difference between the Taxes (in constant 2015 US$) of Gabon in 2010 and the Taxes (in constant 2015 US$) of Kyrgyz Republic in 2011?
Your answer should be very brief. 5.31e+08. What is the difference between the Taxes (in constant 2015 US$) of Afghanistan in 2010 and the Taxes (in constant 2015 US$) of Cabo Verde in 2012?
Ensure brevity in your answer.  3.79e+08. What is the difference between the Taxes (in constant 2015 US$) of Afghanistan in 2010 and the Taxes (in constant 2015 US$) of Gabon in 2012?
Give a very brief answer. -8.20e+08. What is the difference between the Taxes (in constant 2015 US$) in Afghanistan in 2010 and the Taxes (in constant 2015 US$) in Kyrgyz Republic in 2012?
Provide a succinct answer. -2.71e+08. What is the difference between the Taxes (in constant 2015 US$) in Cabo Verde in 2010 and the Taxes (in constant 2015 US$) in Gabon in 2012?
Your answer should be compact. -1.20e+09. What is the difference between the Taxes (in constant 2015 US$) of Cabo Verde in 2010 and the Taxes (in constant 2015 US$) of Kyrgyz Republic in 2012?
Offer a very short reply. -6.56e+08. What is the difference between the Taxes (in constant 2015 US$) in Gabon in 2010 and the Taxes (in constant 2015 US$) in Kyrgyz Republic in 2012?
Your answer should be compact. 3.48e+08. What is the difference between the Taxes (in constant 2015 US$) in Afghanistan in 2010 and the Taxes (in constant 2015 US$) in Cabo Verde in 2013?
Your answer should be compact. 3.68e+08. What is the difference between the Taxes (in constant 2015 US$) of Afghanistan in 2010 and the Taxes (in constant 2015 US$) of Gabon in 2013?
Make the answer very short. -8.46e+08. What is the difference between the Taxes (in constant 2015 US$) of Afghanistan in 2010 and the Taxes (in constant 2015 US$) of Kyrgyz Republic in 2013?
Make the answer very short. -4.24e+08. What is the difference between the Taxes (in constant 2015 US$) in Cabo Verde in 2010 and the Taxes (in constant 2015 US$) in Gabon in 2013?
Give a very brief answer. -1.23e+09. What is the difference between the Taxes (in constant 2015 US$) in Cabo Verde in 2010 and the Taxes (in constant 2015 US$) in Kyrgyz Republic in 2013?
Offer a terse response. -8.09e+08. What is the difference between the Taxes (in constant 2015 US$) in Gabon in 2010 and the Taxes (in constant 2015 US$) in Kyrgyz Republic in 2013?
Provide a succinct answer. 1.94e+08. What is the difference between the Taxes (in constant 2015 US$) of Afghanistan in 2010 and the Taxes (in constant 2015 US$) of Cabo Verde in 2014?
Keep it short and to the point. 3.40e+08. What is the difference between the Taxes (in constant 2015 US$) of Afghanistan in 2010 and the Taxes (in constant 2015 US$) of Gabon in 2014?
Make the answer very short. -9.15e+08. What is the difference between the Taxes (in constant 2015 US$) of Afghanistan in 2010 and the Taxes (in constant 2015 US$) of Kyrgyz Republic in 2014?
Your answer should be compact. -4.49e+08. What is the difference between the Taxes (in constant 2015 US$) of Cabo Verde in 2010 and the Taxes (in constant 2015 US$) of Gabon in 2014?
Provide a succinct answer. -1.30e+09. What is the difference between the Taxes (in constant 2015 US$) in Cabo Verde in 2010 and the Taxes (in constant 2015 US$) in Kyrgyz Republic in 2014?
Provide a short and direct response. -8.33e+08. What is the difference between the Taxes (in constant 2015 US$) in Gabon in 2010 and the Taxes (in constant 2015 US$) in Kyrgyz Republic in 2014?
Offer a very short reply. 1.70e+08. What is the difference between the Taxes (in constant 2015 US$) in Afghanistan in 2011 and the Taxes (in constant 2015 US$) in Cabo Verde in 2012?
Your answer should be compact. 4.63e+08. What is the difference between the Taxes (in constant 2015 US$) of Afghanistan in 2011 and the Taxes (in constant 2015 US$) of Gabon in 2012?
Make the answer very short. -7.36e+08. What is the difference between the Taxes (in constant 2015 US$) in Afghanistan in 2011 and the Taxes (in constant 2015 US$) in Kyrgyz Republic in 2012?
Offer a very short reply. -1.87e+08. What is the difference between the Taxes (in constant 2015 US$) in Cabo Verde in 2011 and the Taxes (in constant 2015 US$) in Gabon in 2012?
Your answer should be compact. -1.16e+09. What is the difference between the Taxes (in constant 2015 US$) in Cabo Verde in 2011 and the Taxes (in constant 2015 US$) in Kyrgyz Republic in 2012?
Keep it short and to the point. -6.10e+08. What is the difference between the Taxes (in constant 2015 US$) of Gabon in 2011 and the Taxes (in constant 2015 US$) of Kyrgyz Republic in 2012?
Provide a succinct answer. 6.18e+08. What is the difference between the Taxes (in constant 2015 US$) in Afghanistan in 2011 and the Taxes (in constant 2015 US$) in Cabo Verde in 2013?
Offer a terse response. 4.52e+08. What is the difference between the Taxes (in constant 2015 US$) of Afghanistan in 2011 and the Taxes (in constant 2015 US$) of Gabon in 2013?
Your answer should be compact. -7.62e+08. What is the difference between the Taxes (in constant 2015 US$) in Afghanistan in 2011 and the Taxes (in constant 2015 US$) in Kyrgyz Republic in 2013?
Provide a succinct answer. -3.40e+08. What is the difference between the Taxes (in constant 2015 US$) in Cabo Verde in 2011 and the Taxes (in constant 2015 US$) in Gabon in 2013?
Your answer should be very brief. -1.19e+09. What is the difference between the Taxes (in constant 2015 US$) of Cabo Verde in 2011 and the Taxes (in constant 2015 US$) of Kyrgyz Republic in 2013?
Keep it short and to the point. -7.63e+08. What is the difference between the Taxes (in constant 2015 US$) in Gabon in 2011 and the Taxes (in constant 2015 US$) in Kyrgyz Republic in 2013?
Keep it short and to the point. 4.64e+08. What is the difference between the Taxes (in constant 2015 US$) in Afghanistan in 2011 and the Taxes (in constant 2015 US$) in Cabo Verde in 2014?
Offer a very short reply. 4.24e+08. What is the difference between the Taxes (in constant 2015 US$) in Afghanistan in 2011 and the Taxes (in constant 2015 US$) in Gabon in 2014?
Provide a short and direct response. -8.31e+08. What is the difference between the Taxes (in constant 2015 US$) in Afghanistan in 2011 and the Taxes (in constant 2015 US$) in Kyrgyz Republic in 2014?
Offer a very short reply. -3.65e+08. What is the difference between the Taxes (in constant 2015 US$) in Cabo Verde in 2011 and the Taxes (in constant 2015 US$) in Gabon in 2014?
Keep it short and to the point. -1.25e+09. What is the difference between the Taxes (in constant 2015 US$) of Cabo Verde in 2011 and the Taxes (in constant 2015 US$) of Kyrgyz Republic in 2014?
Offer a terse response. -7.87e+08. What is the difference between the Taxes (in constant 2015 US$) of Gabon in 2011 and the Taxes (in constant 2015 US$) of Kyrgyz Republic in 2014?
Provide a succinct answer. 4.40e+08. What is the difference between the Taxes (in constant 2015 US$) of Afghanistan in 2012 and the Taxes (in constant 2015 US$) of Cabo Verde in 2013?
Provide a short and direct response. 5.73e+08. What is the difference between the Taxes (in constant 2015 US$) of Afghanistan in 2012 and the Taxes (in constant 2015 US$) of Gabon in 2013?
Your response must be concise. -6.41e+08. What is the difference between the Taxes (in constant 2015 US$) of Afghanistan in 2012 and the Taxes (in constant 2015 US$) of Kyrgyz Republic in 2013?
Make the answer very short. -2.19e+08. What is the difference between the Taxes (in constant 2015 US$) of Cabo Verde in 2012 and the Taxes (in constant 2015 US$) of Gabon in 2013?
Keep it short and to the point. -1.23e+09. What is the difference between the Taxes (in constant 2015 US$) in Cabo Verde in 2012 and the Taxes (in constant 2015 US$) in Kyrgyz Republic in 2013?
Offer a terse response. -8.03e+08. What is the difference between the Taxes (in constant 2015 US$) in Gabon in 2012 and the Taxes (in constant 2015 US$) in Kyrgyz Republic in 2013?
Make the answer very short. 3.96e+08. What is the difference between the Taxes (in constant 2015 US$) in Afghanistan in 2012 and the Taxes (in constant 2015 US$) in Cabo Verde in 2014?
Provide a short and direct response. 5.45e+08. What is the difference between the Taxes (in constant 2015 US$) of Afghanistan in 2012 and the Taxes (in constant 2015 US$) of Gabon in 2014?
Ensure brevity in your answer.  -7.10e+08. What is the difference between the Taxes (in constant 2015 US$) in Afghanistan in 2012 and the Taxes (in constant 2015 US$) in Kyrgyz Republic in 2014?
Offer a very short reply. -2.44e+08. What is the difference between the Taxes (in constant 2015 US$) of Cabo Verde in 2012 and the Taxes (in constant 2015 US$) of Gabon in 2014?
Provide a succinct answer. -1.29e+09. What is the difference between the Taxes (in constant 2015 US$) of Cabo Verde in 2012 and the Taxes (in constant 2015 US$) of Kyrgyz Republic in 2014?
Offer a very short reply. -8.28e+08. What is the difference between the Taxes (in constant 2015 US$) of Gabon in 2012 and the Taxes (in constant 2015 US$) of Kyrgyz Republic in 2014?
Your answer should be very brief. 3.72e+08. What is the difference between the Taxes (in constant 2015 US$) of Afghanistan in 2013 and the Taxes (in constant 2015 US$) of Cabo Verde in 2014?
Give a very brief answer. 5.72e+08. What is the difference between the Taxes (in constant 2015 US$) in Afghanistan in 2013 and the Taxes (in constant 2015 US$) in Gabon in 2014?
Make the answer very short. -6.83e+08. What is the difference between the Taxes (in constant 2015 US$) of Afghanistan in 2013 and the Taxes (in constant 2015 US$) of Kyrgyz Republic in 2014?
Give a very brief answer. -2.17e+08. What is the difference between the Taxes (in constant 2015 US$) in Cabo Verde in 2013 and the Taxes (in constant 2015 US$) in Gabon in 2014?
Ensure brevity in your answer.  -1.28e+09. What is the difference between the Taxes (in constant 2015 US$) of Cabo Verde in 2013 and the Taxes (in constant 2015 US$) of Kyrgyz Republic in 2014?
Give a very brief answer. -8.17e+08. What is the difference between the Taxes (in constant 2015 US$) in Gabon in 2013 and the Taxes (in constant 2015 US$) in Kyrgyz Republic in 2014?
Your response must be concise. 3.98e+08. What is the average Taxes (in constant 2015 US$) of Afghanistan per year?
Your answer should be very brief. 5.76e+08. What is the average Taxes (in constant 2015 US$) of Cabo Verde per year?
Provide a short and direct response. 2.29e+08. What is the average Taxes (in constant 2015 US$) of Gabon per year?
Offer a very short reply. 1.20e+09. What is the average Taxes (in constant 2015 US$) of Kyrgyz Republic per year?
Offer a very short reply. 7.26e+08. In the year 2007, what is the difference between the Taxes (in constant 2015 US$) of Afghanistan and Taxes (in constant 2015 US$) of Cabo Verde?
Your answer should be very brief. 5.87e+07. In the year 2007, what is the difference between the Taxes (in constant 2015 US$) in Afghanistan and Taxes (in constant 2015 US$) in Gabon?
Your response must be concise. -5.40e+08. In the year 2007, what is the difference between the Taxes (in constant 2015 US$) of Afghanistan and Taxes (in constant 2015 US$) of Kyrgyz Republic?
Give a very brief answer. -2.49e+08. In the year 2007, what is the difference between the Taxes (in constant 2015 US$) of Cabo Verde and Taxes (in constant 2015 US$) of Gabon?
Provide a succinct answer. -5.99e+08. In the year 2007, what is the difference between the Taxes (in constant 2015 US$) of Cabo Verde and Taxes (in constant 2015 US$) of Kyrgyz Republic?
Provide a short and direct response. -3.07e+08. In the year 2007, what is the difference between the Taxes (in constant 2015 US$) of Gabon and Taxes (in constant 2015 US$) of Kyrgyz Republic?
Provide a succinct answer. 2.92e+08. In the year 2008, what is the difference between the Taxes (in constant 2015 US$) of Afghanistan and Taxes (in constant 2015 US$) of Cabo Verde?
Your response must be concise. 3.58e+07. In the year 2008, what is the difference between the Taxes (in constant 2015 US$) in Afghanistan and Taxes (in constant 2015 US$) in Gabon?
Your answer should be very brief. -5.01e+08. In the year 2008, what is the difference between the Taxes (in constant 2015 US$) of Afghanistan and Taxes (in constant 2015 US$) of Kyrgyz Republic?
Make the answer very short. -3.94e+08. In the year 2008, what is the difference between the Taxes (in constant 2015 US$) of Cabo Verde and Taxes (in constant 2015 US$) of Gabon?
Keep it short and to the point. -5.37e+08. In the year 2008, what is the difference between the Taxes (in constant 2015 US$) in Cabo Verde and Taxes (in constant 2015 US$) in Kyrgyz Republic?
Your answer should be very brief. -4.30e+08. In the year 2008, what is the difference between the Taxes (in constant 2015 US$) of Gabon and Taxes (in constant 2015 US$) of Kyrgyz Republic?
Give a very brief answer. 1.07e+08. In the year 2009, what is the difference between the Taxes (in constant 2015 US$) of Afghanistan and Taxes (in constant 2015 US$) of Cabo Verde?
Make the answer very short. 2.33e+08. In the year 2009, what is the difference between the Taxes (in constant 2015 US$) in Afghanistan and Taxes (in constant 2015 US$) in Gabon?
Ensure brevity in your answer.  -4.86e+08. In the year 2009, what is the difference between the Taxes (in constant 2015 US$) in Afghanistan and Taxes (in constant 2015 US$) in Kyrgyz Republic?
Your answer should be compact. -7.41e+07. In the year 2009, what is the difference between the Taxes (in constant 2015 US$) of Cabo Verde and Taxes (in constant 2015 US$) of Gabon?
Ensure brevity in your answer.  -7.19e+08. In the year 2009, what is the difference between the Taxes (in constant 2015 US$) in Cabo Verde and Taxes (in constant 2015 US$) in Kyrgyz Republic?
Keep it short and to the point. -3.07e+08. In the year 2009, what is the difference between the Taxes (in constant 2015 US$) of Gabon and Taxes (in constant 2015 US$) of Kyrgyz Republic?
Provide a short and direct response. 4.12e+08. In the year 2010, what is the difference between the Taxes (in constant 2015 US$) of Afghanistan and Taxes (in constant 2015 US$) of Cabo Verde?
Provide a short and direct response. 3.85e+08. In the year 2010, what is the difference between the Taxes (in constant 2015 US$) of Afghanistan and Taxes (in constant 2015 US$) of Gabon?
Make the answer very short. -6.19e+08. In the year 2010, what is the difference between the Taxes (in constant 2015 US$) of Afghanistan and Taxes (in constant 2015 US$) of Kyrgyz Republic?
Your response must be concise. 1.05e+08. In the year 2010, what is the difference between the Taxes (in constant 2015 US$) of Cabo Verde and Taxes (in constant 2015 US$) of Gabon?
Make the answer very short. -1.00e+09. In the year 2010, what is the difference between the Taxes (in constant 2015 US$) of Cabo Verde and Taxes (in constant 2015 US$) of Kyrgyz Republic?
Keep it short and to the point. -2.80e+08. In the year 2010, what is the difference between the Taxes (in constant 2015 US$) of Gabon and Taxes (in constant 2015 US$) of Kyrgyz Republic?
Your answer should be compact. 7.23e+08. In the year 2011, what is the difference between the Taxes (in constant 2015 US$) of Afghanistan and Taxes (in constant 2015 US$) of Cabo Verde?
Give a very brief answer. 4.23e+08. In the year 2011, what is the difference between the Taxes (in constant 2015 US$) in Afghanistan and Taxes (in constant 2015 US$) in Gabon?
Your answer should be very brief. -8.05e+08. In the year 2011, what is the difference between the Taxes (in constant 2015 US$) of Afghanistan and Taxes (in constant 2015 US$) of Kyrgyz Republic?
Ensure brevity in your answer.  -4.09e+06. In the year 2011, what is the difference between the Taxes (in constant 2015 US$) in Cabo Verde and Taxes (in constant 2015 US$) in Gabon?
Give a very brief answer. -1.23e+09. In the year 2011, what is the difference between the Taxes (in constant 2015 US$) in Cabo Verde and Taxes (in constant 2015 US$) in Kyrgyz Republic?
Provide a short and direct response. -4.27e+08. In the year 2011, what is the difference between the Taxes (in constant 2015 US$) in Gabon and Taxes (in constant 2015 US$) in Kyrgyz Republic?
Offer a terse response. 8.01e+08. In the year 2012, what is the difference between the Taxes (in constant 2015 US$) in Afghanistan and Taxes (in constant 2015 US$) in Cabo Verde?
Your answer should be compact. 5.84e+08. In the year 2012, what is the difference between the Taxes (in constant 2015 US$) of Afghanistan and Taxes (in constant 2015 US$) of Gabon?
Keep it short and to the point. -6.15e+08. In the year 2012, what is the difference between the Taxes (in constant 2015 US$) in Afghanistan and Taxes (in constant 2015 US$) in Kyrgyz Republic?
Provide a succinct answer. -6.59e+07. In the year 2012, what is the difference between the Taxes (in constant 2015 US$) of Cabo Verde and Taxes (in constant 2015 US$) of Gabon?
Provide a short and direct response. -1.20e+09. In the year 2012, what is the difference between the Taxes (in constant 2015 US$) in Cabo Verde and Taxes (in constant 2015 US$) in Kyrgyz Republic?
Ensure brevity in your answer.  -6.50e+08. In the year 2012, what is the difference between the Taxes (in constant 2015 US$) of Gabon and Taxes (in constant 2015 US$) of Kyrgyz Republic?
Provide a short and direct response. 5.49e+08. In the year 2013, what is the difference between the Taxes (in constant 2015 US$) of Afghanistan and Taxes (in constant 2015 US$) of Cabo Verde?
Your answer should be very brief. 6.00e+08. In the year 2013, what is the difference between the Taxes (in constant 2015 US$) of Afghanistan and Taxes (in constant 2015 US$) of Gabon?
Give a very brief answer. -6.15e+08. In the year 2013, what is the difference between the Taxes (in constant 2015 US$) in Afghanistan and Taxes (in constant 2015 US$) in Kyrgyz Republic?
Offer a terse response. -1.92e+08. In the year 2013, what is the difference between the Taxes (in constant 2015 US$) of Cabo Verde and Taxes (in constant 2015 US$) of Gabon?
Provide a short and direct response. -1.21e+09. In the year 2013, what is the difference between the Taxes (in constant 2015 US$) of Cabo Verde and Taxes (in constant 2015 US$) of Kyrgyz Republic?
Make the answer very short. -7.93e+08. In the year 2013, what is the difference between the Taxes (in constant 2015 US$) of Gabon and Taxes (in constant 2015 US$) of Kyrgyz Republic?
Offer a terse response. 4.22e+08. In the year 2014, what is the difference between the Taxes (in constant 2015 US$) of Afghanistan and Taxes (in constant 2015 US$) of Cabo Verde?
Ensure brevity in your answer.  4.55e+08. In the year 2014, what is the difference between the Taxes (in constant 2015 US$) in Afghanistan and Taxes (in constant 2015 US$) in Gabon?
Provide a succinct answer. -8.00e+08. In the year 2014, what is the difference between the Taxes (in constant 2015 US$) in Afghanistan and Taxes (in constant 2015 US$) in Kyrgyz Republic?
Offer a very short reply. -3.34e+08. In the year 2014, what is the difference between the Taxes (in constant 2015 US$) of Cabo Verde and Taxes (in constant 2015 US$) of Gabon?
Give a very brief answer. -1.25e+09. In the year 2014, what is the difference between the Taxes (in constant 2015 US$) of Cabo Verde and Taxes (in constant 2015 US$) of Kyrgyz Republic?
Your answer should be very brief. -7.89e+08. In the year 2014, what is the difference between the Taxes (in constant 2015 US$) of Gabon and Taxes (in constant 2015 US$) of Kyrgyz Republic?
Your answer should be very brief. 4.66e+08. What is the ratio of the Taxes (in constant 2015 US$) of Afghanistan in 2007 to that in 2008?
Provide a succinct answer. 0.94. What is the ratio of the Taxes (in constant 2015 US$) of Cabo Verde in 2007 to that in 2008?
Give a very brief answer. 0.84. What is the ratio of the Taxes (in constant 2015 US$) of Gabon in 2007 to that in 2008?
Ensure brevity in your answer.  1.03. What is the ratio of the Taxes (in constant 2015 US$) in Kyrgyz Republic in 2007 to that in 2008?
Give a very brief answer. 0.76. What is the ratio of the Taxes (in constant 2015 US$) of Afghanistan in 2007 to that in 2009?
Offer a very short reply. 0.6. What is the ratio of the Taxes (in constant 2015 US$) in Cabo Verde in 2007 to that in 2009?
Offer a terse response. 0.98. What is the ratio of the Taxes (in constant 2015 US$) in Gabon in 2007 to that in 2009?
Offer a terse response. 0.87. What is the ratio of the Taxes (in constant 2015 US$) in Afghanistan in 2007 to that in 2010?
Offer a very short reply. 0.44. What is the ratio of the Taxes (in constant 2015 US$) in Cabo Verde in 2007 to that in 2010?
Provide a short and direct response. 0.98. What is the ratio of the Taxes (in constant 2015 US$) in Gabon in 2007 to that in 2010?
Offer a terse response. 0.66. What is the ratio of the Taxes (in constant 2015 US$) in Kyrgyz Republic in 2007 to that in 2010?
Your answer should be compact. 1.04. What is the ratio of the Taxes (in constant 2015 US$) in Afghanistan in 2007 to that in 2011?
Keep it short and to the point. 0.39. What is the ratio of the Taxes (in constant 2015 US$) of Cabo Verde in 2007 to that in 2011?
Offer a terse response. 0.8. What is the ratio of the Taxes (in constant 2015 US$) of Gabon in 2007 to that in 2011?
Make the answer very short. 0.54. What is the ratio of the Taxes (in constant 2015 US$) in Kyrgyz Republic in 2007 to that in 2011?
Give a very brief answer. 0.75. What is the ratio of the Taxes (in constant 2015 US$) in Afghanistan in 2007 to that in 2012?
Make the answer very short. 0.33. What is the ratio of the Taxes (in constant 2015 US$) in Cabo Verde in 2007 to that in 2012?
Ensure brevity in your answer.  0.95. What is the ratio of the Taxes (in constant 2015 US$) in Gabon in 2007 to that in 2012?
Make the answer very short. 0.57. What is the ratio of the Taxes (in constant 2015 US$) in Kyrgyz Republic in 2007 to that in 2012?
Make the answer very short. 0.59. What is the ratio of the Taxes (in constant 2015 US$) of Afghanistan in 2007 to that in 2013?
Your answer should be compact. 0.32. What is the ratio of the Taxes (in constant 2015 US$) of Cabo Verde in 2007 to that in 2013?
Keep it short and to the point. 0.91. What is the ratio of the Taxes (in constant 2015 US$) of Gabon in 2007 to that in 2013?
Offer a terse response. 0.56. What is the ratio of the Taxes (in constant 2015 US$) in Kyrgyz Republic in 2007 to that in 2013?
Your answer should be very brief. 0.5. What is the ratio of the Taxes (in constant 2015 US$) of Afghanistan in 2007 to that in 2014?
Make the answer very short. 0.37. What is the ratio of the Taxes (in constant 2015 US$) in Cabo Verde in 2007 to that in 2014?
Offer a terse response. 0.81. What is the ratio of the Taxes (in constant 2015 US$) in Gabon in 2007 to that in 2014?
Offer a very short reply. 0.53. What is the ratio of the Taxes (in constant 2015 US$) in Kyrgyz Republic in 2007 to that in 2014?
Give a very brief answer. 0.49. What is the ratio of the Taxes (in constant 2015 US$) in Afghanistan in 2008 to that in 2009?
Give a very brief answer. 0.64. What is the ratio of the Taxes (in constant 2015 US$) in Cabo Verde in 2008 to that in 2009?
Give a very brief answer. 1.17. What is the ratio of the Taxes (in constant 2015 US$) in Gabon in 2008 to that in 2009?
Keep it short and to the point. 0.84. What is the ratio of the Taxes (in constant 2015 US$) of Kyrgyz Republic in 2008 to that in 2009?
Provide a short and direct response. 1.31. What is the ratio of the Taxes (in constant 2015 US$) in Afghanistan in 2008 to that in 2010?
Give a very brief answer. 0.47. What is the ratio of the Taxes (in constant 2015 US$) in Cabo Verde in 2008 to that in 2010?
Keep it short and to the point. 1.16. What is the ratio of the Taxes (in constant 2015 US$) of Gabon in 2008 to that in 2010?
Offer a terse response. 0.64. What is the ratio of the Taxes (in constant 2015 US$) in Kyrgyz Republic in 2008 to that in 2010?
Make the answer very short. 1.37. What is the ratio of the Taxes (in constant 2015 US$) in Afghanistan in 2008 to that in 2011?
Your answer should be compact. 0.41. What is the ratio of the Taxes (in constant 2015 US$) of Cabo Verde in 2008 to that in 2011?
Keep it short and to the point. 0.95. What is the ratio of the Taxes (in constant 2015 US$) of Gabon in 2008 to that in 2011?
Provide a short and direct response. 0.53. What is the ratio of the Taxes (in constant 2015 US$) of Kyrgyz Republic in 2008 to that in 2011?
Offer a very short reply. 0.99. What is the ratio of the Taxes (in constant 2015 US$) of Afghanistan in 2008 to that in 2012?
Keep it short and to the point. 0.35. What is the ratio of the Taxes (in constant 2015 US$) in Cabo Verde in 2008 to that in 2012?
Your answer should be very brief. 1.13. What is the ratio of the Taxes (in constant 2015 US$) of Gabon in 2008 to that in 2012?
Offer a very short reply. 0.55. What is the ratio of the Taxes (in constant 2015 US$) in Kyrgyz Republic in 2008 to that in 2012?
Provide a short and direct response. 0.78. What is the ratio of the Taxes (in constant 2015 US$) of Afghanistan in 2008 to that in 2013?
Ensure brevity in your answer.  0.34. What is the ratio of the Taxes (in constant 2015 US$) in Cabo Verde in 2008 to that in 2013?
Make the answer very short. 1.08. What is the ratio of the Taxes (in constant 2015 US$) of Gabon in 2008 to that in 2013?
Make the answer very short. 0.54. What is the ratio of the Taxes (in constant 2015 US$) of Kyrgyz Republic in 2008 to that in 2013?
Provide a short and direct response. 0.66. What is the ratio of the Taxes (in constant 2015 US$) in Afghanistan in 2008 to that in 2014?
Provide a succinct answer. 0.4. What is the ratio of the Taxes (in constant 2015 US$) of Cabo Verde in 2008 to that in 2014?
Provide a succinct answer. 0.96. What is the ratio of the Taxes (in constant 2015 US$) of Gabon in 2008 to that in 2014?
Offer a very short reply. 0.52. What is the ratio of the Taxes (in constant 2015 US$) of Kyrgyz Republic in 2008 to that in 2014?
Your answer should be compact. 0.65. What is the ratio of the Taxes (in constant 2015 US$) of Afghanistan in 2009 to that in 2010?
Your answer should be compact. 0.74. What is the ratio of the Taxes (in constant 2015 US$) in Cabo Verde in 2009 to that in 2010?
Your answer should be very brief. 0.99. What is the ratio of the Taxes (in constant 2015 US$) in Gabon in 2009 to that in 2010?
Provide a short and direct response. 0.76. What is the ratio of the Taxes (in constant 2015 US$) in Kyrgyz Republic in 2009 to that in 2010?
Provide a short and direct response. 1.05. What is the ratio of the Taxes (in constant 2015 US$) in Afghanistan in 2009 to that in 2011?
Ensure brevity in your answer.  0.65. What is the ratio of the Taxes (in constant 2015 US$) in Cabo Verde in 2009 to that in 2011?
Provide a succinct answer. 0.81. What is the ratio of the Taxes (in constant 2015 US$) of Gabon in 2009 to that in 2011?
Offer a very short reply. 0.62. What is the ratio of the Taxes (in constant 2015 US$) of Kyrgyz Republic in 2009 to that in 2011?
Your answer should be compact. 0.75. What is the ratio of the Taxes (in constant 2015 US$) in Afghanistan in 2009 to that in 2012?
Keep it short and to the point. 0.55. What is the ratio of the Taxes (in constant 2015 US$) in Gabon in 2009 to that in 2012?
Offer a terse response. 0.66. What is the ratio of the Taxes (in constant 2015 US$) of Kyrgyz Republic in 2009 to that in 2012?
Ensure brevity in your answer.  0.6. What is the ratio of the Taxes (in constant 2015 US$) in Afghanistan in 2009 to that in 2013?
Make the answer very short. 0.53. What is the ratio of the Taxes (in constant 2015 US$) of Cabo Verde in 2009 to that in 2013?
Your answer should be compact. 0.92. What is the ratio of the Taxes (in constant 2015 US$) in Gabon in 2009 to that in 2013?
Ensure brevity in your answer.  0.64. What is the ratio of the Taxes (in constant 2015 US$) of Kyrgyz Republic in 2009 to that in 2013?
Provide a short and direct response. 0.51. What is the ratio of the Taxes (in constant 2015 US$) in Afghanistan in 2009 to that in 2014?
Ensure brevity in your answer.  0.62. What is the ratio of the Taxes (in constant 2015 US$) of Cabo Verde in 2009 to that in 2014?
Your answer should be very brief. 0.82. What is the ratio of the Taxes (in constant 2015 US$) of Gabon in 2009 to that in 2014?
Provide a succinct answer. 0.61. What is the ratio of the Taxes (in constant 2015 US$) of Kyrgyz Republic in 2009 to that in 2014?
Offer a terse response. 0.49. What is the ratio of the Taxes (in constant 2015 US$) in Afghanistan in 2010 to that in 2011?
Offer a very short reply. 0.88. What is the ratio of the Taxes (in constant 2015 US$) in Cabo Verde in 2010 to that in 2011?
Ensure brevity in your answer.  0.82. What is the ratio of the Taxes (in constant 2015 US$) in Gabon in 2010 to that in 2011?
Keep it short and to the point. 0.82. What is the ratio of the Taxes (in constant 2015 US$) of Kyrgyz Republic in 2010 to that in 2011?
Give a very brief answer. 0.72. What is the ratio of the Taxes (in constant 2015 US$) of Afghanistan in 2010 to that in 2012?
Your response must be concise. 0.74. What is the ratio of the Taxes (in constant 2015 US$) in Cabo Verde in 2010 to that in 2012?
Give a very brief answer. 0.97. What is the ratio of the Taxes (in constant 2015 US$) in Gabon in 2010 to that in 2012?
Keep it short and to the point. 0.86. What is the ratio of the Taxes (in constant 2015 US$) of Kyrgyz Republic in 2010 to that in 2012?
Offer a very short reply. 0.57. What is the ratio of the Taxes (in constant 2015 US$) of Afghanistan in 2010 to that in 2013?
Give a very brief answer. 0.72. What is the ratio of the Taxes (in constant 2015 US$) in Cabo Verde in 2010 to that in 2013?
Your answer should be compact. 0.93. What is the ratio of the Taxes (in constant 2015 US$) in Gabon in 2010 to that in 2013?
Offer a very short reply. 0.84. What is the ratio of the Taxes (in constant 2015 US$) in Kyrgyz Republic in 2010 to that in 2013?
Offer a terse response. 0.48. What is the ratio of the Taxes (in constant 2015 US$) of Afghanistan in 2010 to that in 2014?
Offer a very short reply. 0.84. What is the ratio of the Taxes (in constant 2015 US$) in Cabo Verde in 2010 to that in 2014?
Offer a very short reply. 0.83. What is the ratio of the Taxes (in constant 2015 US$) in Gabon in 2010 to that in 2014?
Provide a short and direct response. 0.8. What is the ratio of the Taxes (in constant 2015 US$) of Kyrgyz Republic in 2010 to that in 2014?
Offer a terse response. 0.47. What is the ratio of the Taxes (in constant 2015 US$) of Afghanistan in 2011 to that in 2012?
Your response must be concise. 0.85. What is the ratio of the Taxes (in constant 2015 US$) of Cabo Verde in 2011 to that in 2012?
Offer a terse response. 1.19. What is the ratio of the Taxes (in constant 2015 US$) in Gabon in 2011 to that in 2012?
Provide a short and direct response. 1.05. What is the ratio of the Taxes (in constant 2015 US$) of Kyrgyz Republic in 2011 to that in 2012?
Keep it short and to the point. 0.79. What is the ratio of the Taxes (in constant 2015 US$) in Afghanistan in 2011 to that in 2013?
Your answer should be very brief. 0.82. What is the ratio of the Taxes (in constant 2015 US$) in Cabo Verde in 2011 to that in 2013?
Your response must be concise. 1.13. What is the ratio of the Taxes (in constant 2015 US$) of Gabon in 2011 to that in 2013?
Ensure brevity in your answer.  1.03. What is the ratio of the Taxes (in constant 2015 US$) in Kyrgyz Republic in 2011 to that in 2013?
Ensure brevity in your answer.  0.67. What is the ratio of the Taxes (in constant 2015 US$) of Afghanistan in 2011 to that in 2014?
Make the answer very short. 0.96. What is the ratio of the Taxes (in constant 2015 US$) of Cabo Verde in 2011 to that in 2014?
Your response must be concise. 1.01. What is the ratio of the Taxes (in constant 2015 US$) in Gabon in 2011 to that in 2014?
Ensure brevity in your answer.  0.98. What is the ratio of the Taxes (in constant 2015 US$) of Kyrgyz Republic in 2011 to that in 2014?
Provide a short and direct response. 0.65. What is the ratio of the Taxes (in constant 2015 US$) of Afghanistan in 2012 to that in 2013?
Make the answer very short. 0.97. What is the ratio of the Taxes (in constant 2015 US$) in Cabo Verde in 2012 to that in 2013?
Make the answer very short. 0.95. What is the ratio of the Taxes (in constant 2015 US$) of Gabon in 2012 to that in 2013?
Offer a terse response. 0.98. What is the ratio of the Taxes (in constant 2015 US$) in Kyrgyz Republic in 2012 to that in 2013?
Your answer should be very brief. 0.85. What is the ratio of the Taxes (in constant 2015 US$) of Afghanistan in 2012 to that in 2014?
Offer a very short reply. 1.13. What is the ratio of the Taxes (in constant 2015 US$) of Cabo Verde in 2012 to that in 2014?
Offer a terse response. 0.85. What is the ratio of the Taxes (in constant 2015 US$) in Kyrgyz Republic in 2012 to that in 2014?
Provide a short and direct response. 0.83. What is the ratio of the Taxes (in constant 2015 US$) of Afghanistan in 2013 to that in 2014?
Your response must be concise. 1.16. What is the ratio of the Taxes (in constant 2015 US$) in Cabo Verde in 2013 to that in 2014?
Give a very brief answer. 0.89. What is the ratio of the Taxes (in constant 2015 US$) of Gabon in 2013 to that in 2014?
Your answer should be very brief. 0.95. What is the ratio of the Taxes (in constant 2015 US$) in Kyrgyz Republic in 2013 to that in 2014?
Provide a succinct answer. 0.98. What is the difference between the highest and the second highest Taxes (in constant 2015 US$) in Afghanistan?
Provide a short and direct response. 2.70e+07. What is the difference between the highest and the second highest Taxes (in constant 2015 US$) in Cabo Verde?
Offer a very short reply. 1.39e+06. What is the difference between the highest and the second highest Taxes (in constant 2015 US$) in Gabon?
Your answer should be compact. 2.60e+07. What is the difference between the highest and the second highest Taxes (in constant 2015 US$) in Kyrgyz Republic?
Your answer should be compact. 2.44e+07. What is the difference between the highest and the lowest Taxes (in constant 2015 US$) in Afghanistan?
Your response must be concise. 5.63e+08. What is the difference between the highest and the lowest Taxes (in constant 2015 US$) in Cabo Verde?
Make the answer very short. 5.10e+07. What is the difference between the highest and the lowest Taxes (in constant 2015 US$) in Gabon?
Your response must be concise. 7.28e+08. What is the difference between the highest and the lowest Taxes (in constant 2015 US$) in Kyrgyz Republic?
Give a very brief answer. 5.53e+08. 